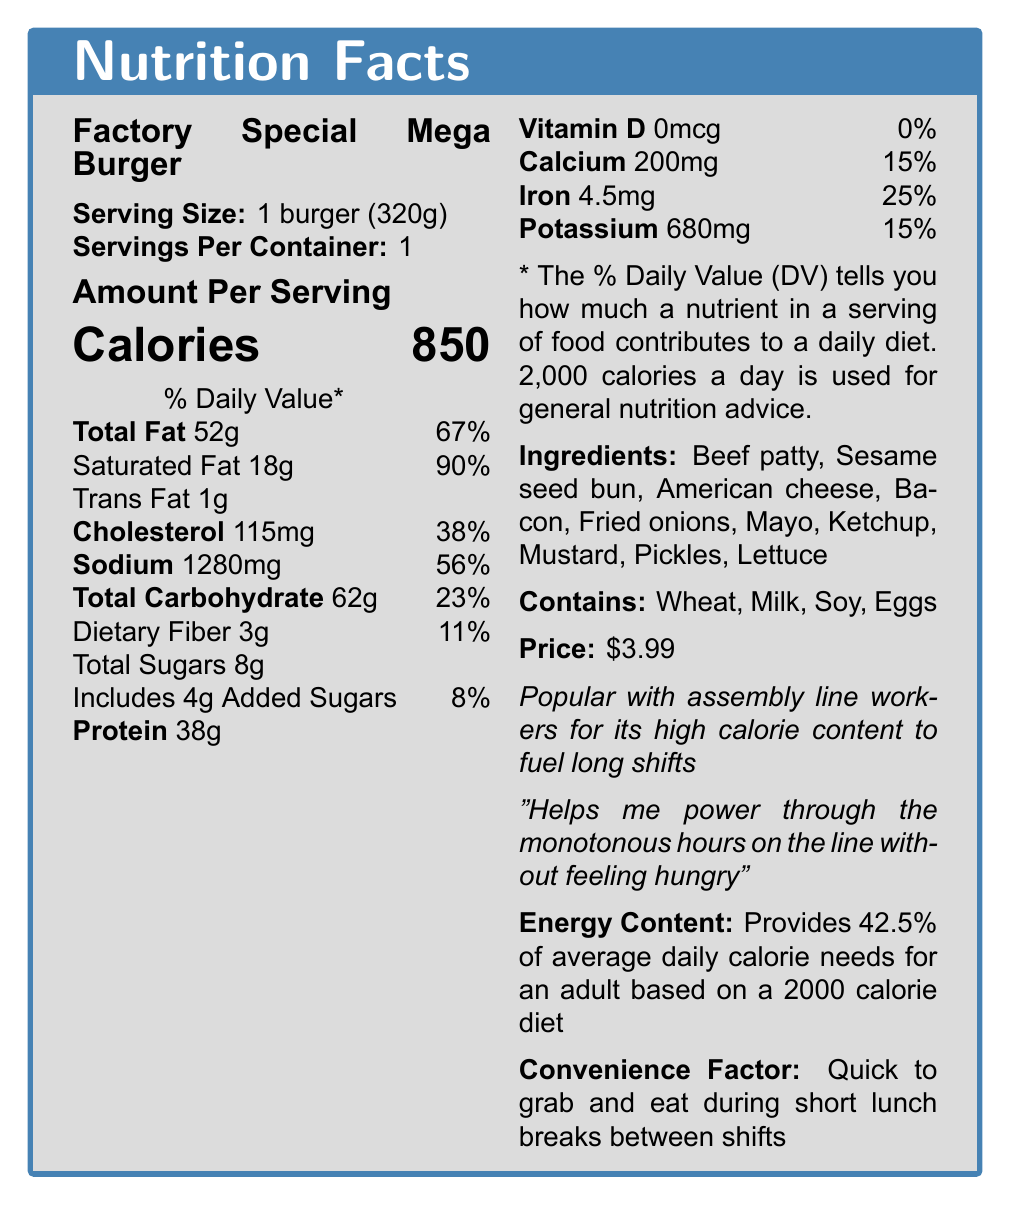what is the serving size? The document clearly states the serving size as 1 burger (320g).
Answer: 1 burger (320g) how many calories does one Factory Special Mega Burger contain? The document mentions that the burger contains 850 calories per serving.
Answer: 850 what is the price of the Factory Special Mega Burger? The document lists the price as $3.99.
Answer: $3.99 what percentage of the daily value of saturated fat does the burger provide? The document shows that the burger provides 90% of the daily value of saturated fat.
Answer: 90% how much protein is in the Factory Special Mega Burger? It is stated that the burger contains 38g of protein.
Answer: 38g which of the following allergens are present in the Factory Special Mega Burger? A. Gluten B. Wheat C. Peanuts D. Tree nuts The document lists the allergens present in the burger, which include Wheat, Milk, Soy, and Eggs.
Answer: B. Wheat how much sodium does the Factory Special Mega Burger contain? A. 1280mg B. 890mg C. 1150mg D. 680mg The sodium content of the burger is listed as 1280mg in the document.
Answer: A. 1280mg does the Factory Special Mega Burger contain any vitamin D? The document states that the burger contains 0mcg of vitamin D, which is 0% of the daily value.
Answer: No summarize the main nutritional aspects of the Factory Special Mega Burger. The document provides detailed information about the nutritional content, price, and other features of the Factory Special Mega Burger, emphasizing its suitability as a high-calorie, budget-friendly option for factory workers.
Answer: The Factory Special Mega Burger is a high-calorie lunch option containing 850 calories and 52g of total fat per serving. It has 18g of saturated fat, 1g of trans fat, 115mg of cholesterol, and 1280mg of sodium. The burger also provides 38g of protein and contributions to daily values include 15% calcium, 25% iron, and 15% potassium. The burger contains wheat, milk, soy, and eggs allergens. It is priced at $3.99 and is popular for its high calorie content which helps fuel long shifts for factory workers. how many grams of dietary fiber does the Factory Special Mega Burger contain? The document specifies that the burger contains 3g of dietary fiber.
Answer: 3g how much percentage of an adult's average daily calorie need does this burger provide? According to the document, the burger provides 42.5% of the average daily calorie needs for an adult based on a 2000 calorie diet.
Answer: 42.5% how many servings per container are there? The document states that there is 1 serving per container.
Answer: 1 what are the main ingredients in the Factory Special Mega Burger? The document lists these as the main ingredients of the burger.
Answer: Beef patty, Sesame seed bun, American cheese, Bacon, Fried onions, Mayo, Ketchup, Mustard, Pickles, Lettuce does the burger have added sugars? The document mentions that the burger includes 4g of added sugars.
Answer: Yes what is the total carbohydrate content of the burger? The total carbohydrate content of the burger is listed as 62g.
Answer: 62g is the Factory Special Mega Burger suitable for someone with a peanut allergy? The document does not provide information on whether the burger is free of peanuts or peanut derivatives.
Answer: Cannot be determined how much iron does the Factory Special Mega Burger provide? According to the document, the burger contains 4.5mg of iron, contributing 25% of the daily value.
Answer: 4.5mg what is the feedback from the factory workers about the burger? The document includes the workers' feedback mentioning this benefit.
Answer: Helps me power through the monotonous hours on the line without feeling hungry what is the convenience factor mentioned for the Factory Special Mega Burger? The document highlights the burger's convenience factor for quick eating during short lunch breaks.
Answer: Quick to grab and eat during short lunch breaks between shifts 